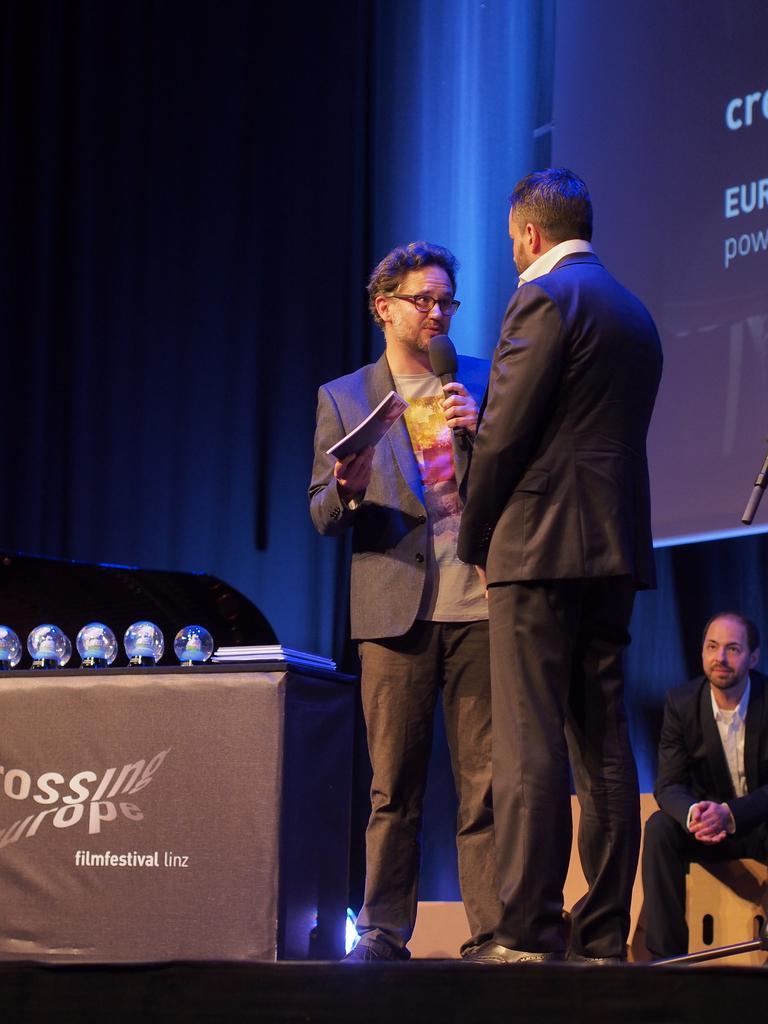In one or two sentences, can you explain what this image depicts? In this image we can see two persons standing on the ground. One person is holding a book and microphone in his hand. On the left side of the image we can see some balls and some objects placed on the table. In the background, we can see a person sitting, screen with some text and group of lights. 